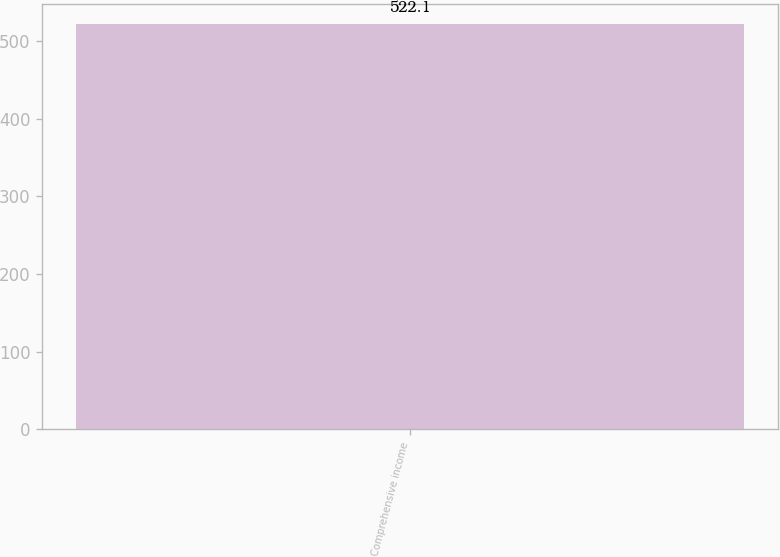Convert chart. <chart><loc_0><loc_0><loc_500><loc_500><bar_chart><fcel>Comprehensive income<nl><fcel>522.1<nl></chart> 